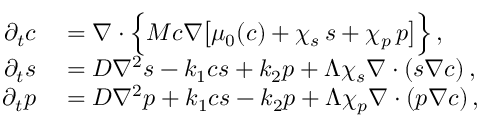Convert formula to latex. <formula><loc_0><loc_0><loc_500><loc_500>\begin{array} { r l } { \partial _ { t } c } & = \boldsymbol \nabla \cdot \left \{ M c \boldsymbol \nabla \left [ \mu _ { 0 } ( c ) + \chi _ { s } \, s + \chi _ { p } \, p \right ] \right \} \, , } \\ { \partial _ { t } s } & = D \nabla ^ { 2 } s - k _ { 1 } c s + k _ { 2 } p + \Lambda \chi _ { s } \boldsymbol \nabla \cdot ( s \boldsymbol \nabla c ) \, , } \\ { \partial _ { t } p } & = D \nabla ^ { 2 } p + k _ { 1 } c s - k _ { 2 } p + \Lambda \chi _ { p } \boldsymbol \nabla \cdot ( p \boldsymbol \nabla c ) \, , } \end{array}</formula> 